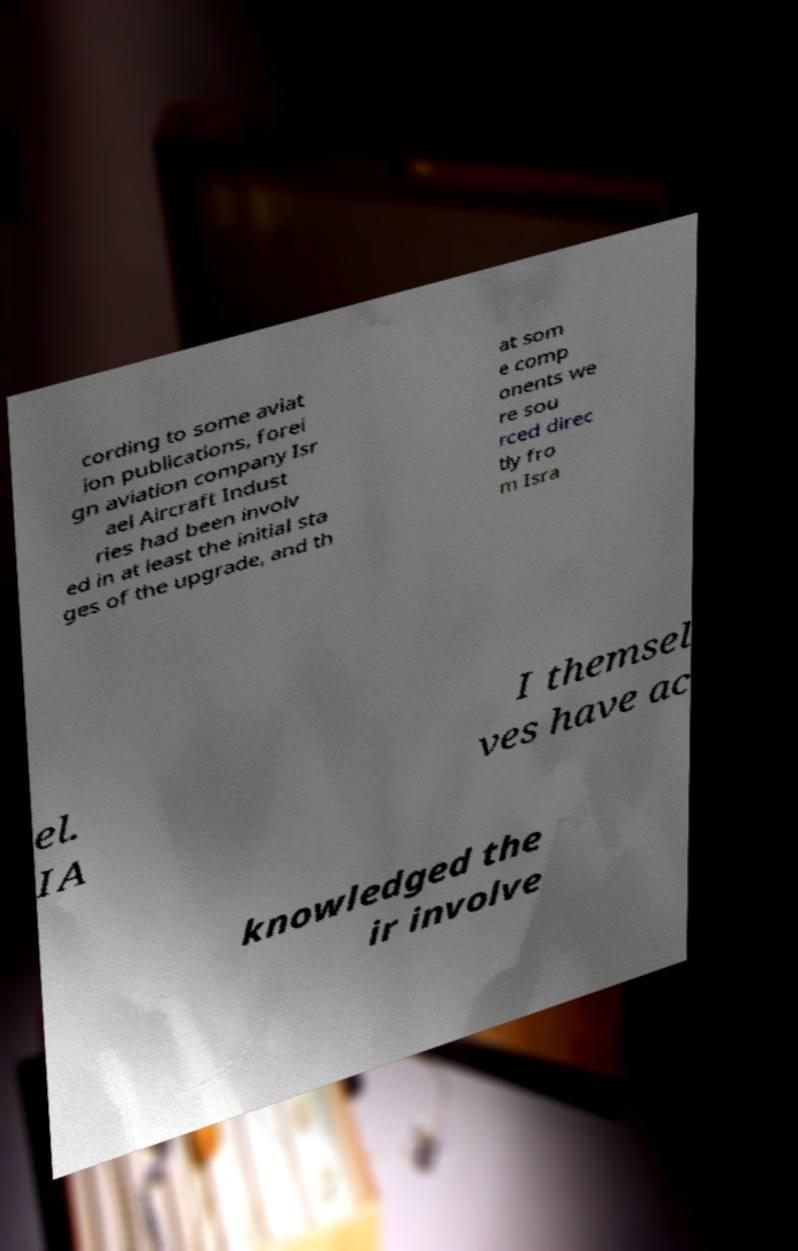For documentation purposes, I need the text within this image transcribed. Could you provide that? cording to some aviat ion publications, forei gn aviation company Isr ael Aircraft Indust ries had been involv ed in at least the initial sta ges of the upgrade, and th at som e comp onents we re sou rced direc tly fro m Isra el. IA I themsel ves have ac knowledged the ir involve 